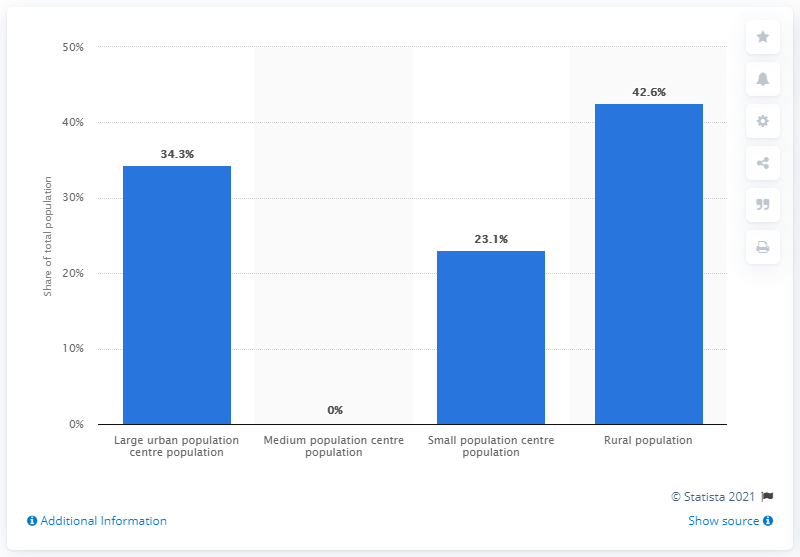Identify some key points in this picture. There is a population distribution with 0% of the population in a medium population center. The rural population is significantly larger than the small population, amounting to 19.5%. 